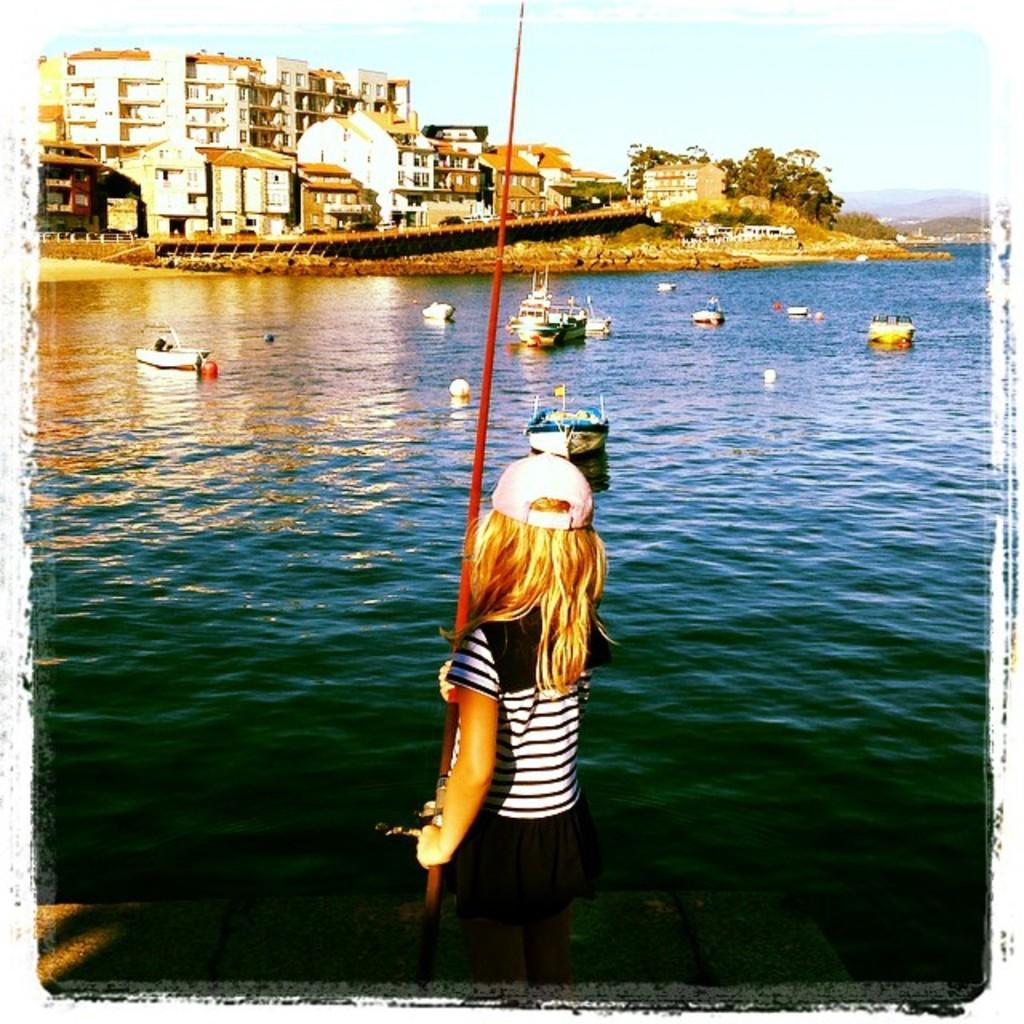Can you describe this image briefly? In the center of the image there is a girl standing by holding the rod. In front of her there are ships in the water. In the background there are are buildings, trees and sky. 